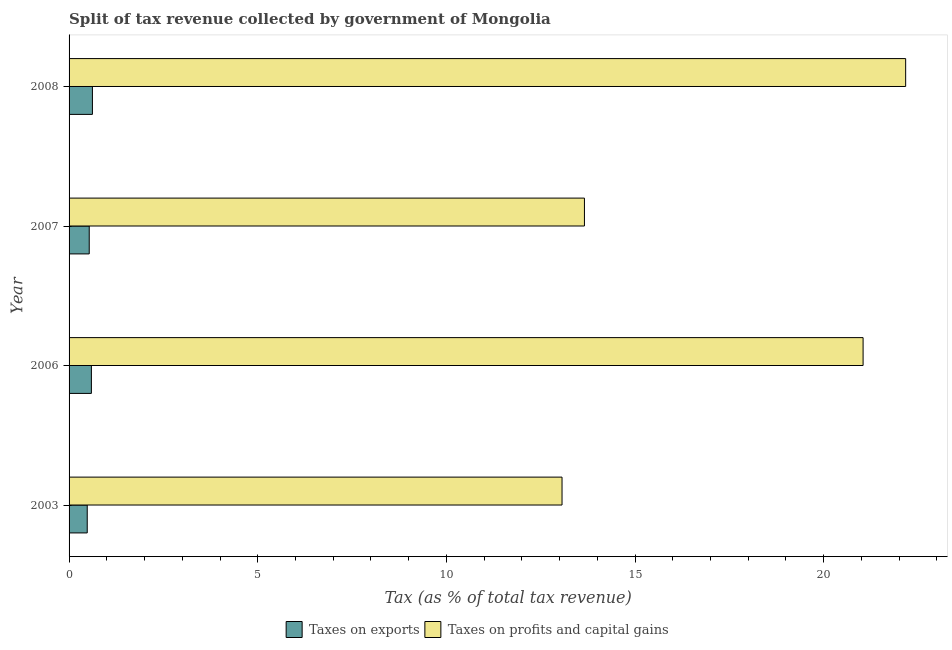How many groups of bars are there?
Provide a succinct answer. 4. Are the number of bars per tick equal to the number of legend labels?
Make the answer very short. Yes. Are the number of bars on each tick of the Y-axis equal?
Your response must be concise. Yes. How many bars are there on the 4th tick from the top?
Provide a succinct answer. 2. How many bars are there on the 2nd tick from the bottom?
Give a very brief answer. 2. What is the label of the 2nd group of bars from the top?
Your answer should be compact. 2007. In how many cases, is the number of bars for a given year not equal to the number of legend labels?
Ensure brevity in your answer.  0. What is the percentage of revenue obtained from taxes on exports in 2007?
Give a very brief answer. 0.53. Across all years, what is the maximum percentage of revenue obtained from taxes on profits and capital gains?
Your response must be concise. 22.17. Across all years, what is the minimum percentage of revenue obtained from taxes on exports?
Offer a terse response. 0.48. What is the total percentage of revenue obtained from taxes on profits and capital gains in the graph?
Your response must be concise. 69.94. What is the difference between the percentage of revenue obtained from taxes on exports in 2003 and that in 2007?
Provide a short and direct response. -0.05. What is the difference between the percentage of revenue obtained from taxes on exports in 2003 and the percentage of revenue obtained from taxes on profits and capital gains in 2006?
Your response must be concise. -20.56. What is the average percentage of revenue obtained from taxes on exports per year?
Your answer should be very brief. 0.56. In the year 2003, what is the difference between the percentage of revenue obtained from taxes on exports and percentage of revenue obtained from taxes on profits and capital gains?
Offer a terse response. -12.58. What is the ratio of the percentage of revenue obtained from taxes on exports in 2006 to that in 2007?
Keep it short and to the point. 1.11. Is the percentage of revenue obtained from taxes on profits and capital gains in 2006 less than that in 2007?
Your answer should be very brief. No. Is the difference between the percentage of revenue obtained from taxes on exports in 2006 and 2008 greater than the difference between the percentage of revenue obtained from taxes on profits and capital gains in 2006 and 2008?
Provide a short and direct response. Yes. What is the difference between the highest and the second highest percentage of revenue obtained from taxes on exports?
Offer a terse response. 0.03. What is the difference between the highest and the lowest percentage of revenue obtained from taxes on profits and capital gains?
Your answer should be very brief. 9.11. In how many years, is the percentage of revenue obtained from taxes on exports greater than the average percentage of revenue obtained from taxes on exports taken over all years?
Your response must be concise. 2. What does the 1st bar from the top in 2003 represents?
Provide a short and direct response. Taxes on profits and capital gains. What does the 1st bar from the bottom in 2003 represents?
Provide a succinct answer. Taxes on exports. How many bars are there?
Make the answer very short. 8. Does the graph contain grids?
Offer a terse response. No. Where does the legend appear in the graph?
Offer a very short reply. Bottom center. How are the legend labels stacked?
Keep it short and to the point. Horizontal. What is the title of the graph?
Ensure brevity in your answer.  Split of tax revenue collected by government of Mongolia. Does "Public credit registry" appear as one of the legend labels in the graph?
Offer a terse response. No. What is the label or title of the X-axis?
Give a very brief answer. Tax (as % of total tax revenue). What is the Tax (as % of total tax revenue) in Taxes on exports in 2003?
Your response must be concise. 0.48. What is the Tax (as % of total tax revenue) in Taxes on profits and capital gains in 2003?
Your response must be concise. 13.06. What is the Tax (as % of total tax revenue) of Taxes on exports in 2006?
Ensure brevity in your answer.  0.59. What is the Tax (as % of total tax revenue) in Taxes on profits and capital gains in 2006?
Keep it short and to the point. 21.04. What is the Tax (as % of total tax revenue) of Taxes on exports in 2007?
Keep it short and to the point. 0.53. What is the Tax (as % of total tax revenue) in Taxes on profits and capital gains in 2007?
Make the answer very short. 13.66. What is the Tax (as % of total tax revenue) in Taxes on exports in 2008?
Offer a terse response. 0.62. What is the Tax (as % of total tax revenue) in Taxes on profits and capital gains in 2008?
Your answer should be compact. 22.17. Across all years, what is the maximum Tax (as % of total tax revenue) of Taxes on exports?
Your answer should be very brief. 0.62. Across all years, what is the maximum Tax (as % of total tax revenue) in Taxes on profits and capital gains?
Offer a very short reply. 22.17. Across all years, what is the minimum Tax (as % of total tax revenue) in Taxes on exports?
Provide a short and direct response. 0.48. Across all years, what is the minimum Tax (as % of total tax revenue) in Taxes on profits and capital gains?
Ensure brevity in your answer.  13.06. What is the total Tax (as % of total tax revenue) of Taxes on exports in the graph?
Offer a terse response. 2.23. What is the total Tax (as % of total tax revenue) of Taxes on profits and capital gains in the graph?
Your response must be concise. 69.94. What is the difference between the Tax (as % of total tax revenue) in Taxes on exports in 2003 and that in 2006?
Your response must be concise. -0.11. What is the difference between the Tax (as % of total tax revenue) in Taxes on profits and capital gains in 2003 and that in 2006?
Offer a terse response. -7.98. What is the difference between the Tax (as % of total tax revenue) of Taxes on exports in 2003 and that in 2007?
Offer a terse response. -0.05. What is the difference between the Tax (as % of total tax revenue) of Taxes on profits and capital gains in 2003 and that in 2007?
Keep it short and to the point. -0.59. What is the difference between the Tax (as % of total tax revenue) in Taxes on exports in 2003 and that in 2008?
Make the answer very short. -0.14. What is the difference between the Tax (as % of total tax revenue) in Taxes on profits and capital gains in 2003 and that in 2008?
Offer a terse response. -9.11. What is the difference between the Tax (as % of total tax revenue) in Taxes on exports in 2006 and that in 2007?
Make the answer very short. 0.06. What is the difference between the Tax (as % of total tax revenue) of Taxes on profits and capital gains in 2006 and that in 2007?
Offer a very short reply. 7.39. What is the difference between the Tax (as % of total tax revenue) in Taxes on exports in 2006 and that in 2008?
Make the answer very short. -0.03. What is the difference between the Tax (as % of total tax revenue) in Taxes on profits and capital gains in 2006 and that in 2008?
Give a very brief answer. -1.13. What is the difference between the Tax (as % of total tax revenue) in Taxes on exports in 2007 and that in 2008?
Your answer should be very brief. -0.08. What is the difference between the Tax (as % of total tax revenue) in Taxes on profits and capital gains in 2007 and that in 2008?
Provide a succinct answer. -8.51. What is the difference between the Tax (as % of total tax revenue) in Taxes on exports in 2003 and the Tax (as % of total tax revenue) in Taxes on profits and capital gains in 2006?
Your answer should be compact. -20.56. What is the difference between the Tax (as % of total tax revenue) of Taxes on exports in 2003 and the Tax (as % of total tax revenue) of Taxes on profits and capital gains in 2007?
Provide a short and direct response. -13.18. What is the difference between the Tax (as % of total tax revenue) in Taxes on exports in 2003 and the Tax (as % of total tax revenue) in Taxes on profits and capital gains in 2008?
Provide a succinct answer. -21.69. What is the difference between the Tax (as % of total tax revenue) in Taxes on exports in 2006 and the Tax (as % of total tax revenue) in Taxes on profits and capital gains in 2007?
Give a very brief answer. -13.07. What is the difference between the Tax (as % of total tax revenue) in Taxes on exports in 2006 and the Tax (as % of total tax revenue) in Taxes on profits and capital gains in 2008?
Keep it short and to the point. -21.58. What is the difference between the Tax (as % of total tax revenue) of Taxes on exports in 2007 and the Tax (as % of total tax revenue) of Taxes on profits and capital gains in 2008?
Your response must be concise. -21.64. What is the average Tax (as % of total tax revenue) in Taxes on exports per year?
Your answer should be very brief. 0.56. What is the average Tax (as % of total tax revenue) of Taxes on profits and capital gains per year?
Provide a short and direct response. 17.49. In the year 2003, what is the difference between the Tax (as % of total tax revenue) in Taxes on exports and Tax (as % of total tax revenue) in Taxes on profits and capital gains?
Make the answer very short. -12.58. In the year 2006, what is the difference between the Tax (as % of total tax revenue) in Taxes on exports and Tax (as % of total tax revenue) in Taxes on profits and capital gains?
Your answer should be very brief. -20.45. In the year 2007, what is the difference between the Tax (as % of total tax revenue) in Taxes on exports and Tax (as % of total tax revenue) in Taxes on profits and capital gains?
Make the answer very short. -13.12. In the year 2008, what is the difference between the Tax (as % of total tax revenue) of Taxes on exports and Tax (as % of total tax revenue) of Taxes on profits and capital gains?
Ensure brevity in your answer.  -21.55. What is the ratio of the Tax (as % of total tax revenue) in Taxes on exports in 2003 to that in 2006?
Your answer should be compact. 0.81. What is the ratio of the Tax (as % of total tax revenue) of Taxes on profits and capital gains in 2003 to that in 2006?
Your answer should be very brief. 0.62. What is the ratio of the Tax (as % of total tax revenue) of Taxes on exports in 2003 to that in 2007?
Make the answer very short. 0.9. What is the ratio of the Tax (as % of total tax revenue) in Taxes on profits and capital gains in 2003 to that in 2007?
Keep it short and to the point. 0.96. What is the ratio of the Tax (as % of total tax revenue) of Taxes on exports in 2003 to that in 2008?
Offer a terse response. 0.78. What is the ratio of the Tax (as % of total tax revenue) in Taxes on profits and capital gains in 2003 to that in 2008?
Keep it short and to the point. 0.59. What is the ratio of the Tax (as % of total tax revenue) of Taxes on exports in 2006 to that in 2007?
Your answer should be compact. 1.11. What is the ratio of the Tax (as % of total tax revenue) of Taxes on profits and capital gains in 2006 to that in 2007?
Offer a terse response. 1.54. What is the ratio of the Tax (as % of total tax revenue) in Taxes on exports in 2006 to that in 2008?
Make the answer very short. 0.96. What is the ratio of the Tax (as % of total tax revenue) of Taxes on profits and capital gains in 2006 to that in 2008?
Ensure brevity in your answer.  0.95. What is the ratio of the Tax (as % of total tax revenue) in Taxes on exports in 2007 to that in 2008?
Keep it short and to the point. 0.86. What is the ratio of the Tax (as % of total tax revenue) of Taxes on profits and capital gains in 2007 to that in 2008?
Your answer should be compact. 0.62. What is the difference between the highest and the second highest Tax (as % of total tax revenue) in Taxes on exports?
Your response must be concise. 0.03. What is the difference between the highest and the second highest Tax (as % of total tax revenue) of Taxes on profits and capital gains?
Keep it short and to the point. 1.13. What is the difference between the highest and the lowest Tax (as % of total tax revenue) of Taxes on exports?
Your answer should be very brief. 0.14. What is the difference between the highest and the lowest Tax (as % of total tax revenue) of Taxes on profits and capital gains?
Provide a succinct answer. 9.11. 